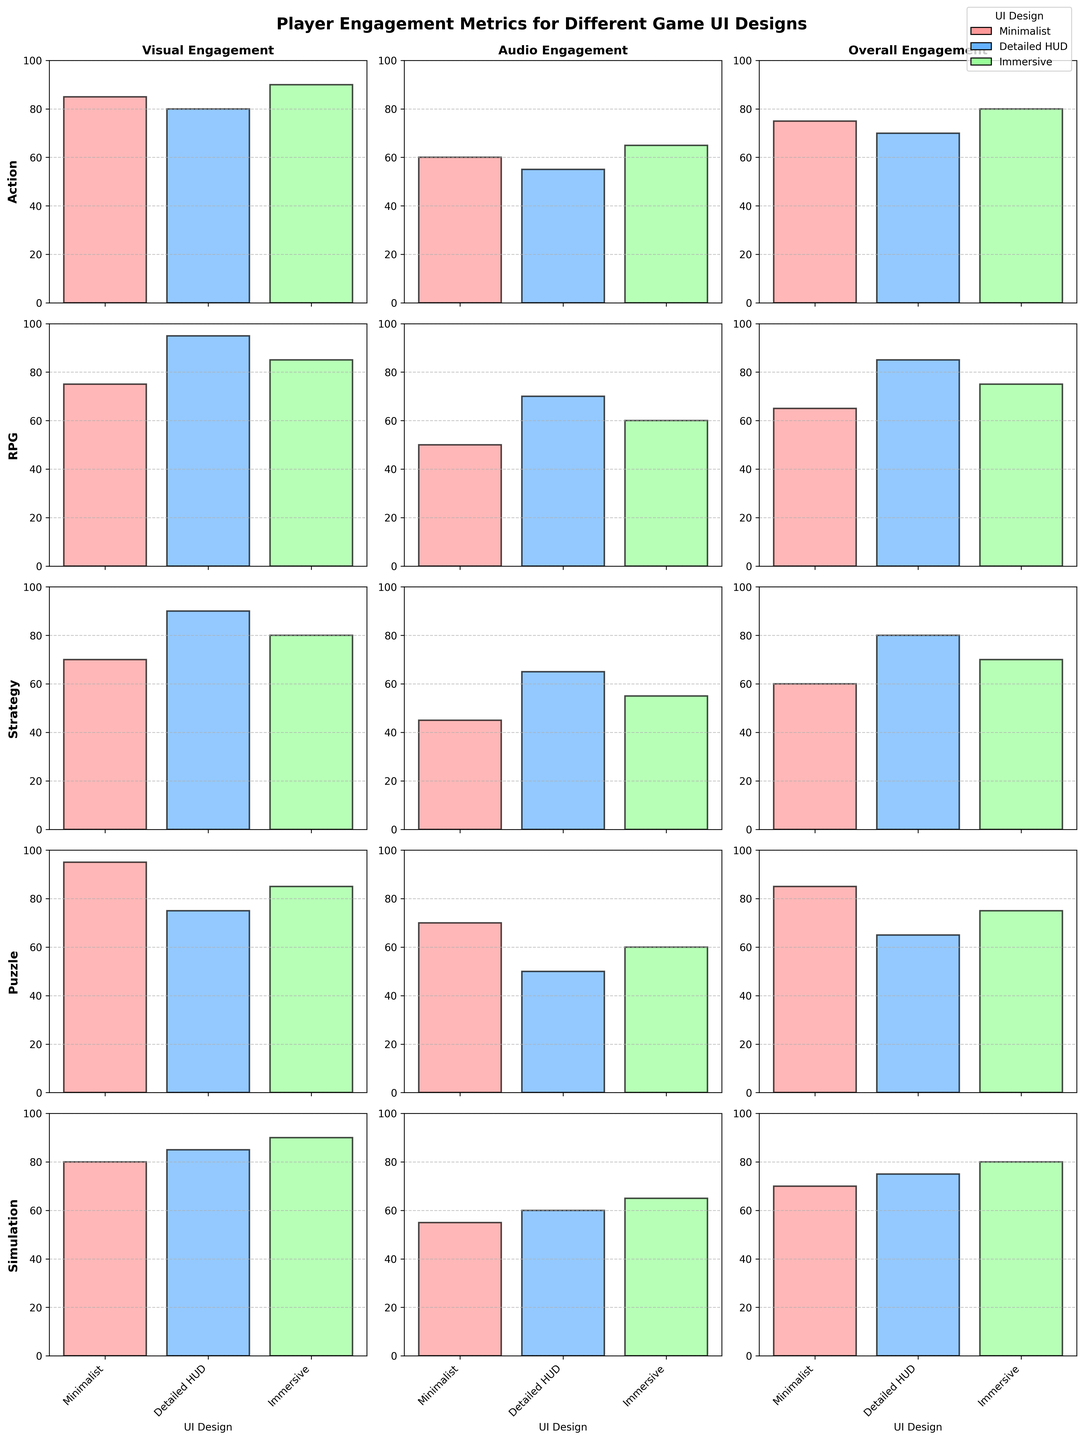What's the title of the figure? The title is located at the top center of the figure and generally provides a concise summary of the content.
Answer: Player Engagement Metrics for Different Game UI Designs Which UI design has the highest overall engagement for RPG games? To find the highest overall engagement for RPG, locate the RPG row and focus on the "Overall Engagement" column. Compare the bar heights: "Detailed HUD" has the highest bar.
Answer: Detailed HUD For puzzle games, which UI design has the lowest audio engagement? Focus on the row for puzzle games and check the "Audio Engagement" column. The shortest bar corresponds to "Detailed HUD".
Answer: Detailed HUD On average, is visual engagement higher for simulation games or for action games? Calculate the average visual engagement for both categories. For simulation: (80 + 85 + 90) / 3 = 85. For action: (85 + 80 + 90) / 3 = 85. Compare the averages: both are equal.
Answer: Equal What is the difference in overall engagement between "Minimalist" and "Immersive" UI designs in strategy games? Locate the strategy games row and find the "Overall Engagement" values for "Minimalist" (60) and "Immersive" (70). Subtract the smaller value from the larger value: 70 - 60 = 10.
Answer: 10 Which game type shows the most significant variation in visual engagement among the different UI designs? Compare the height differences of bars in the "Visual Engagement" column for each game type. RPG shows the highest variation with bars at 75 for "Minimalist", 95 for "Detailed HUD", and 85 for "Immersive".
Answer: RPG Does any game type show higher audio engagement for "Detailed HUD" than "Visual Engagement" for "Minimalist"? Examine the audio engagement for "Detailed HUD" and compare it with visual engagement for "Minimalist" across all game types. No game type meets this condition.
Answer: No What's the overall engagement for action games with "Immersive" UI design? Find the action games row and locate the data point under "Overall Engagement" for "Immersive" UI design.
Answer: 80 Which game type has the most consistent overall engagement across different UI designs? Determine the consistency by evaluating the variations in bar heights in the "Overall Engagement" column. Simulation games have small differences among the three designs (70, 75, 80).
Answer: Simulation 